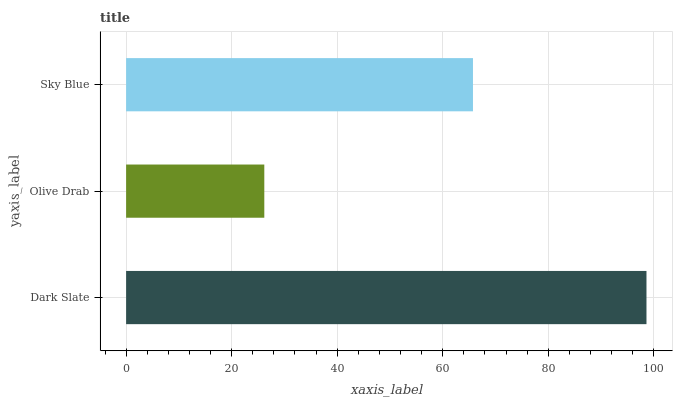Is Olive Drab the minimum?
Answer yes or no. Yes. Is Dark Slate the maximum?
Answer yes or no. Yes. Is Sky Blue the minimum?
Answer yes or no. No. Is Sky Blue the maximum?
Answer yes or no. No. Is Sky Blue greater than Olive Drab?
Answer yes or no. Yes. Is Olive Drab less than Sky Blue?
Answer yes or no. Yes. Is Olive Drab greater than Sky Blue?
Answer yes or no. No. Is Sky Blue less than Olive Drab?
Answer yes or no. No. Is Sky Blue the high median?
Answer yes or no. Yes. Is Sky Blue the low median?
Answer yes or no. Yes. Is Dark Slate the high median?
Answer yes or no. No. Is Olive Drab the low median?
Answer yes or no. No. 